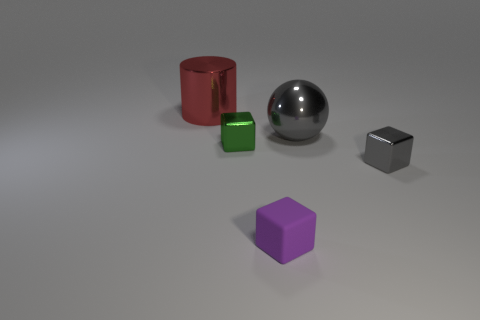Is there another small thing that has the same color as the matte thing?
Your answer should be very brief. No. What is the color of the cylinder that is the same size as the ball?
Your response must be concise. Red. There is a large shiny thing in front of the shiny cylinder; how many small gray cubes are behind it?
Provide a succinct answer. 0. How many objects are either metallic things to the left of the gray metallic block or metal cylinders?
Ensure brevity in your answer.  3. How many big balls are made of the same material as the cylinder?
Provide a succinct answer. 1. There is a thing that is the same color as the big sphere; what is its shape?
Give a very brief answer. Cube. Are there an equal number of purple things that are behind the tiny green object and small gray cubes?
Your response must be concise. No. There is a gray object that is on the right side of the big gray thing; how big is it?
Offer a very short reply. Small. How many tiny things are red metallic objects or yellow matte cylinders?
Give a very brief answer. 0. What is the color of the other metal object that is the same shape as the small green metallic object?
Your response must be concise. Gray. 